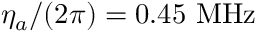<formula> <loc_0><loc_0><loc_500><loc_500>\eta _ { a } / ( 2 \pi ) = 0 . 4 5 M H z</formula> 